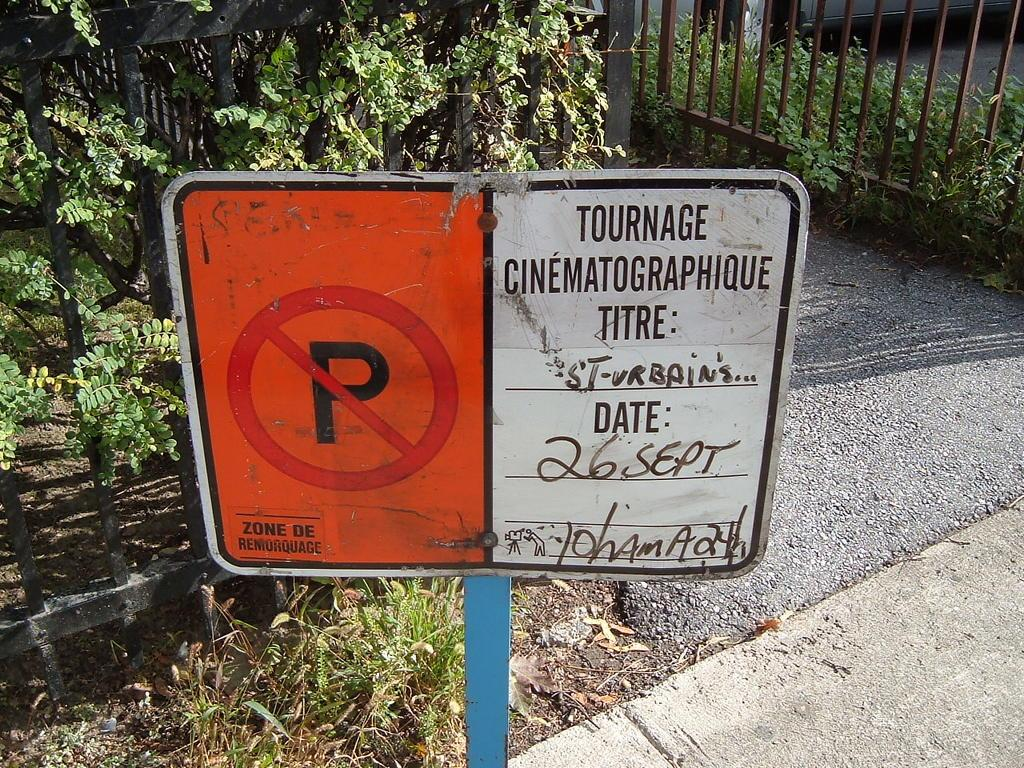What can be seen in the image that is vertical and tall? There is a pole in the image. What is attached to the pole? There is a sign on the pole. What information can be gathered from the sign? Something is written on the sign. What can be seen in the background of the image? There is fencing and plants in the background of the image. What is visible on the ground in the image? There is a path visible in the image. What type of coast can be seen in the image? There is no coast visible in the image; it features a pole with a sign, fencing, plants, and a path. What kind of structure is present in the image? There is no specific structure mentioned in the image; it features a pole with a sign, fencing, plants, and a path. 